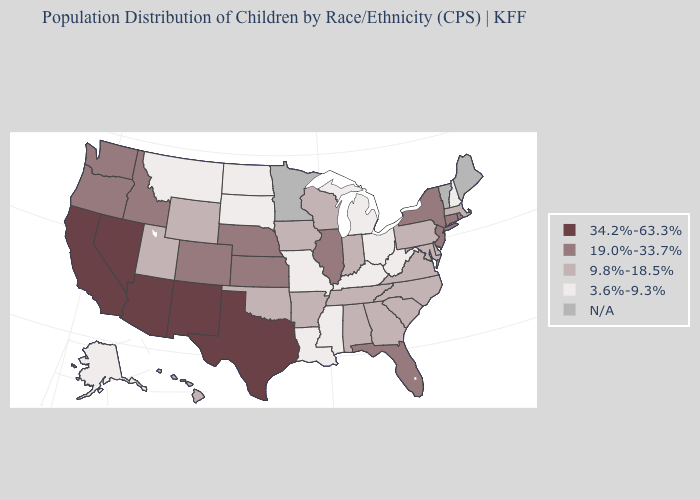Name the states that have a value in the range 3.6%-9.3%?
Be succinct. Alaska, Kentucky, Louisiana, Michigan, Mississippi, Missouri, Montana, New Hampshire, North Dakota, Ohio, South Dakota, West Virginia. Name the states that have a value in the range 9.8%-18.5%?
Be succinct. Alabama, Arkansas, Delaware, Georgia, Hawaii, Indiana, Iowa, Maryland, Massachusetts, North Carolina, Oklahoma, Pennsylvania, South Carolina, Tennessee, Utah, Virginia, Wisconsin, Wyoming. What is the value of Montana?
Quick response, please. 3.6%-9.3%. Does Texas have the highest value in the USA?
Short answer required. Yes. Name the states that have a value in the range 3.6%-9.3%?
Give a very brief answer. Alaska, Kentucky, Louisiana, Michigan, Mississippi, Missouri, Montana, New Hampshire, North Dakota, Ohio, South Dakota, West Virginia. Among the states that border New York , which have the highest value?
Keep it brief. Connecticut, New Jersey. Name the states that have a value in the range 19.0%-33.7%?
Write a very short answer. Colorado, Connecticut, Florida, Idaho, Illinois, Kansas, Nebraska, New Jersey, New York, Oregon, Rhode Island, Washington. Does the first symbol in the legend represent the smallest category?
Answer briefly. No. Which states have the highest value in the USA?
Be succinct. Arizona, California, Nevada, New Mexico, Texas. Name the states that have a value in the range 3.6%-9.3%?
Be succinct. Alaska, Kentucky, Louisiana, Michigan, Mississippi, Missouri, Montana, New Hampshire, North Dakota, Ohio, South Dakota, West Virginia. What is the value of Virginia?
Be succinct. 9.8%-18.5%. What is the value of Texas?
Quick response, please. 34.2%-63.3%. What is the lowest value in the USA?
Write a very short answer. 3.6%-9.3%. What is the value of Washington?
Concise answer only. 19.0%-33.7%. Which states have the lowest value in the MidWest?
Concise answer only. Michigan, Missouri, North Dakota, Ohio, South Dakota. 